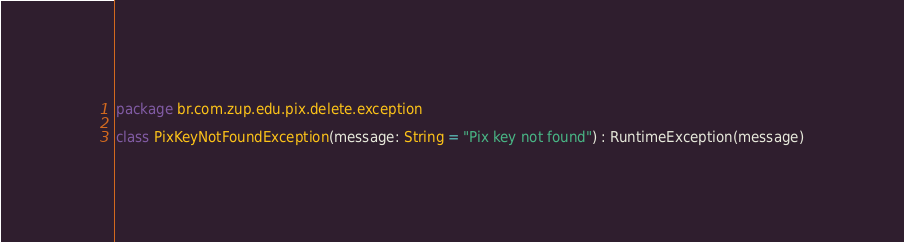Convert code to text. <code><loc_0><loc_0><loc_500><loc_500><_Kotlin_>package br.com.zup.edu.pix.delete.exception

class PixKeyNotFoundException(message: String = "Pix key not found") : RuntimeException(message)
</code> 